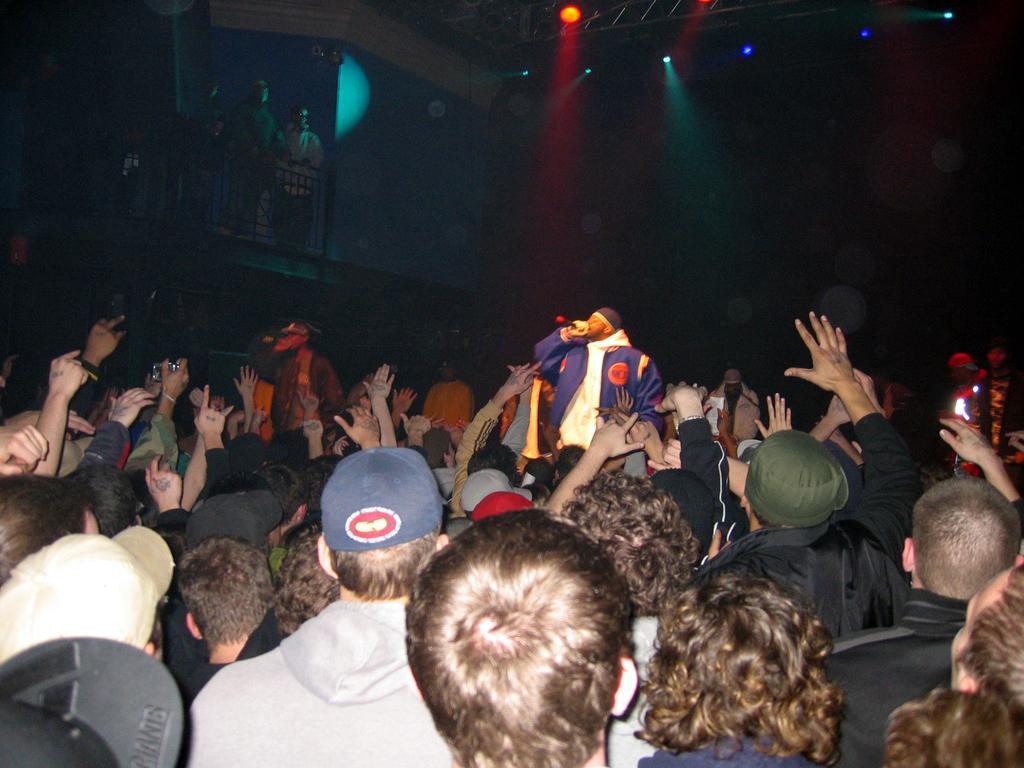Can you describe this image briefly? At the bottom of the image, we can see a group of people. Few people are wearing caps. Background we can see dark, lights, railing and people. 